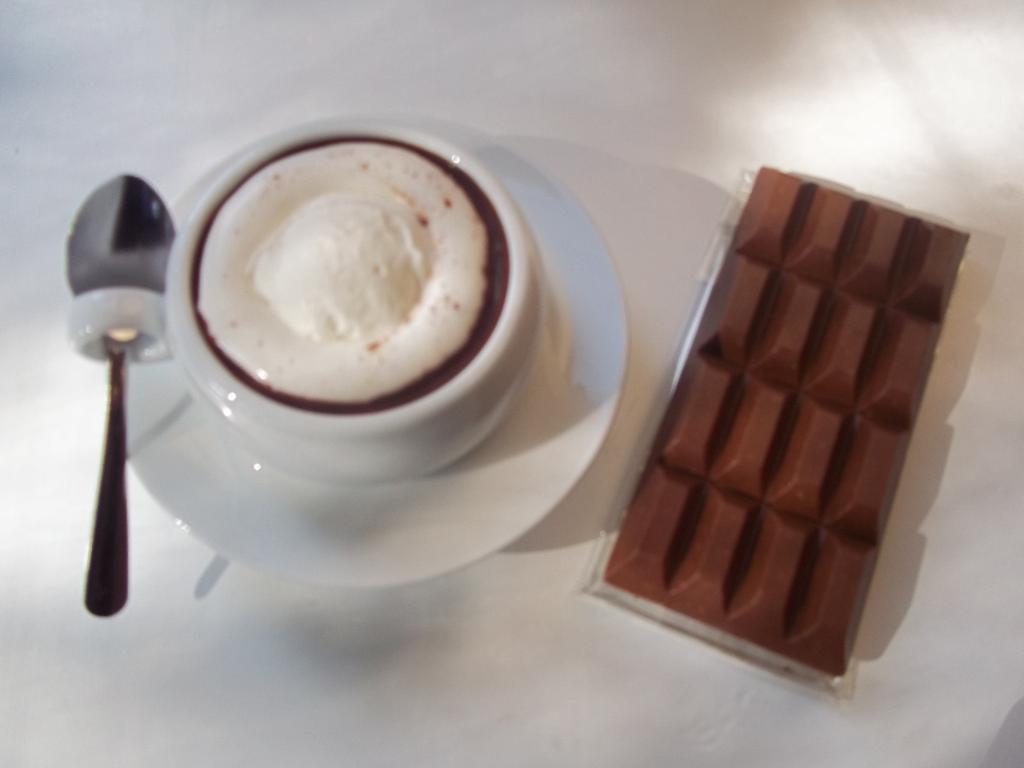Can you describe this image briefly? In this picture there is a cup of tea and a spoon on the left side of the image and there is a chocolate bar on the right side of the image. 